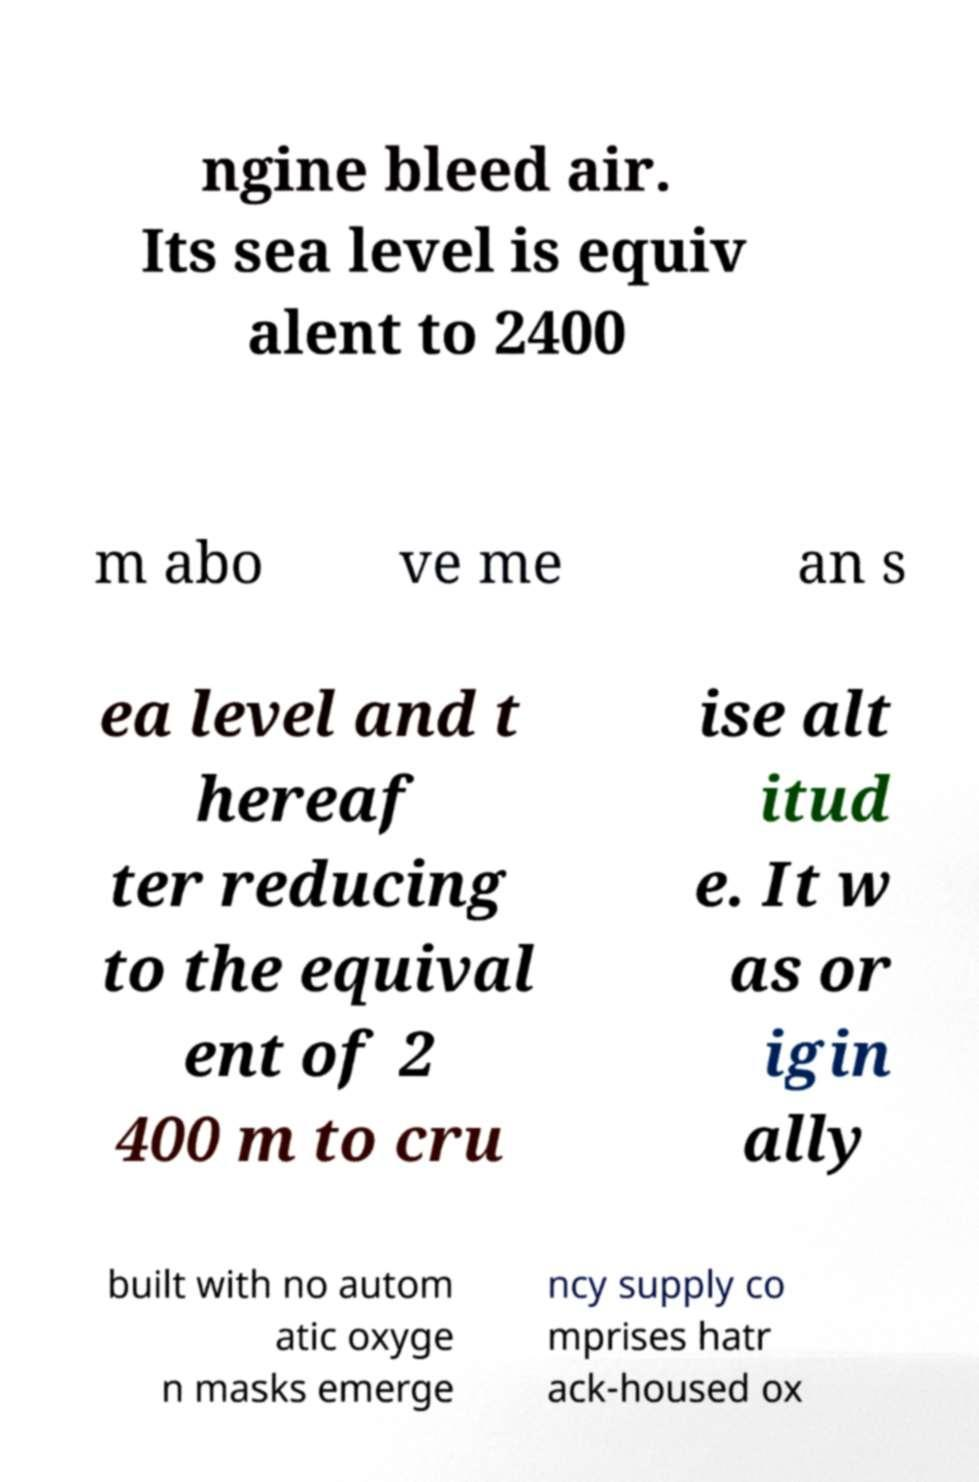What messages or text are displayed in this image? I need them in a readable, typed format. ngine bleed air. Its sea level is equiv alent to 2400 m abo ve me an s ea level and t hereaf ter reducing to the equival ent of 2 400 m to cru ise alt itud e. It w as or igin ally built with no autom atic oxyge n masks emerge ncy supply co mprises hatr ack-housed ox 